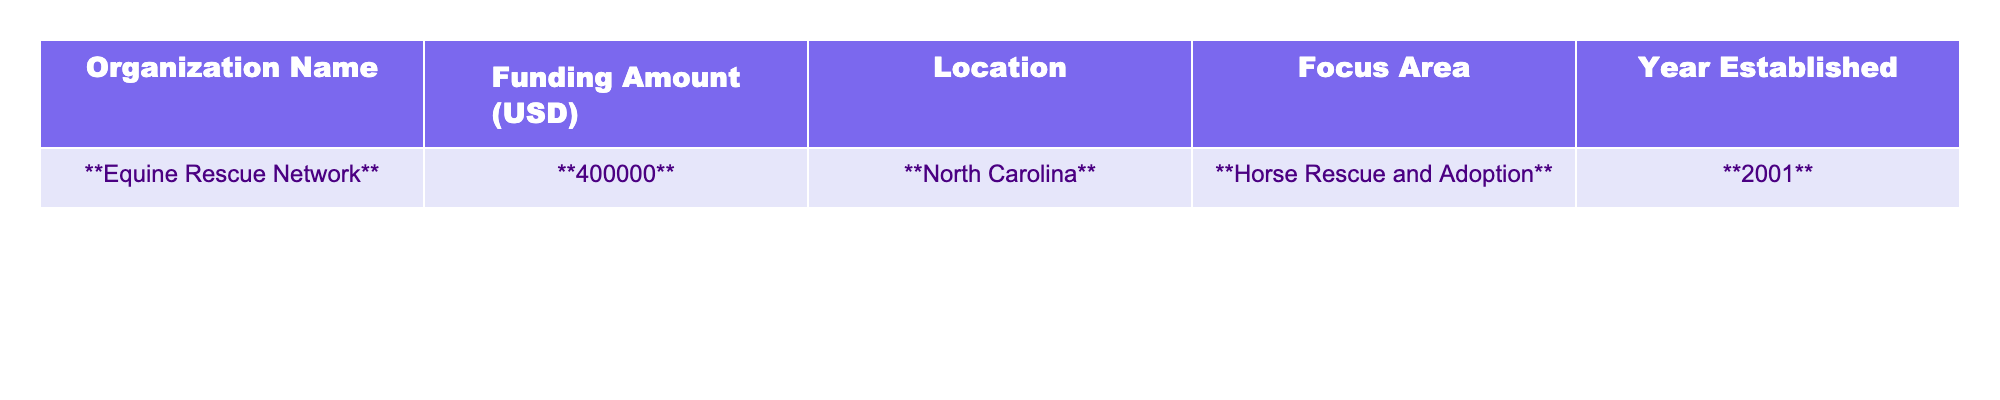What is the funding amount allocated to the Equine Rescue Network? The table clearly states that the funding amount for the Equine Rescue Network is highlighted in bold, showing it as 400,000 USD.
Answer: 400,000 USD In which state is the Equine Rescue Network located? The table indicates that the Equine Rescue Network is located in North Carolina, which is also bolded for emphasis.
Answer: North Carolina What year was the Equine Rescue Network established? According to the table, the year established for the Equine Rescue Network is bolded as 2001.
Answer: 2001 Is the focus area of the Equine Rescue Network solely on horse rescue? The table mentions the focus area of the Equine Rescue Network is "Horse Rescue and Adoption," so it confirms that the focus is solely on horse-related activities.
Answer: Yes How much more funding does the Equine Rescue Network receive compared to the average funding of organizations established before 2000? There is only one organization listed, which is the Equine Rescue Network established in 2001. Since there are no organizations established before 2000, the average is undefined, making it impossible to calculate the difference.
Answer: Undefined What percentage of the funding amount would be allocated to an organization if the total funding for five similar organizations is assumed to be 2,000,000 USD? The funding for the Equine Rescue Network is 400,000 USD. To find the percentage, we divide 400,000 by 2,000,000 and multiply by 100. This gives (400,000 / 2,000,000) * 100 = 20%.
Answer: 20% How many years had the Equine Rescue Network been established by 2023? The Equine Rescue Network was established in 2001, so by 2023, the number of years it has been established is 2023 - 2001 = 22 years.
Answer: 22 years If an organization requires a minimum of 500,000 USD funding to operate effectively, does the Equine Rescue Network meet this requirement? The table indicates that the Equine Rescue Network receives 400,000 USD. Since this amount is less than the required 500,000 USD, it does not meet the funding requirement.
Answer: No 